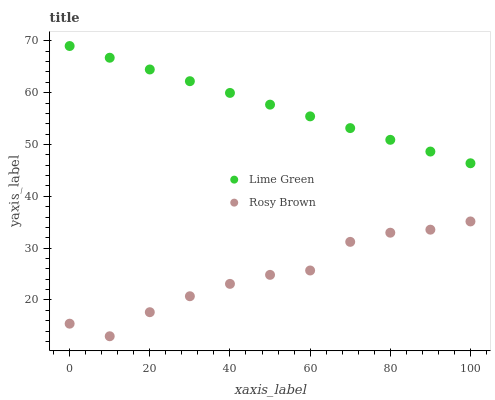Does Rosy Brown have the minimum area under the curve?
Answer yes or no. Yes. Does Lime Green have the maximum area under the curve?
Answer yes or no. Yes. Does Lime Green have the minimum area under the curve?
Answer yes or no. No. Is Lime Green the smoothest?
Answer yes or no. Yes. Is Rosy Brown the roughest?
Answer yes or no. Yes. Is Lime Green the roughest?
Answer yes or no. No. Does Rosy Brown have the lowest value?
Answer yes or no. Yes. Does Lime Green have the lowest value?
Answer yes or no. No. Does Lime Green have the highest value?
Answer yes or no. Yes. Is Rosy Brown less than Lime Green?
Answer yes or no. Yes. Is Lime Green greater than Rosy Brown?
Answer yes or no. Yes. Does Rosy Brown intersect Lime Green?
Answer yes or no. No. 